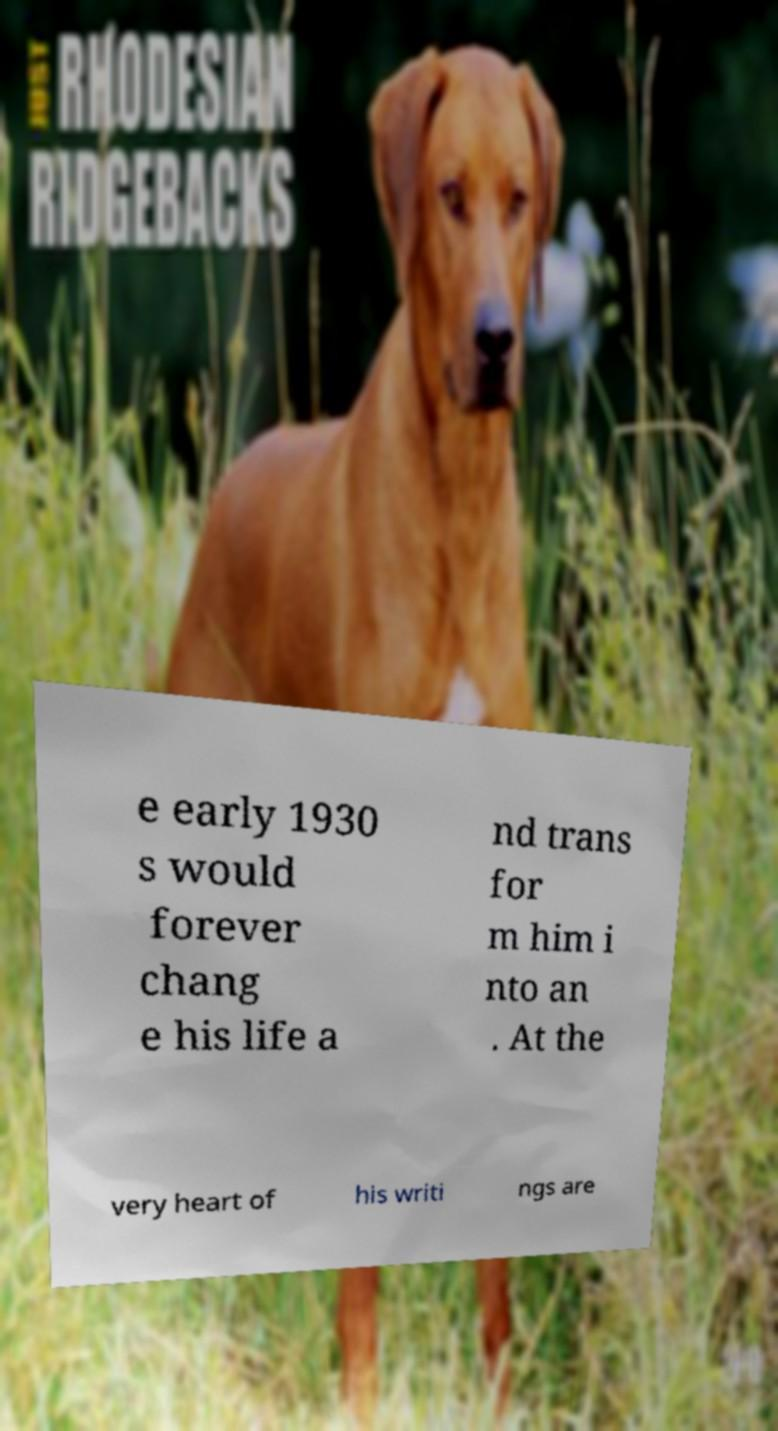What messages or text are displayed in this image? I need them in a readable, typed format. e early 1930 s would forever chang e his life a nd trans for m him i nto an . At the very heart of his writi ngs are 